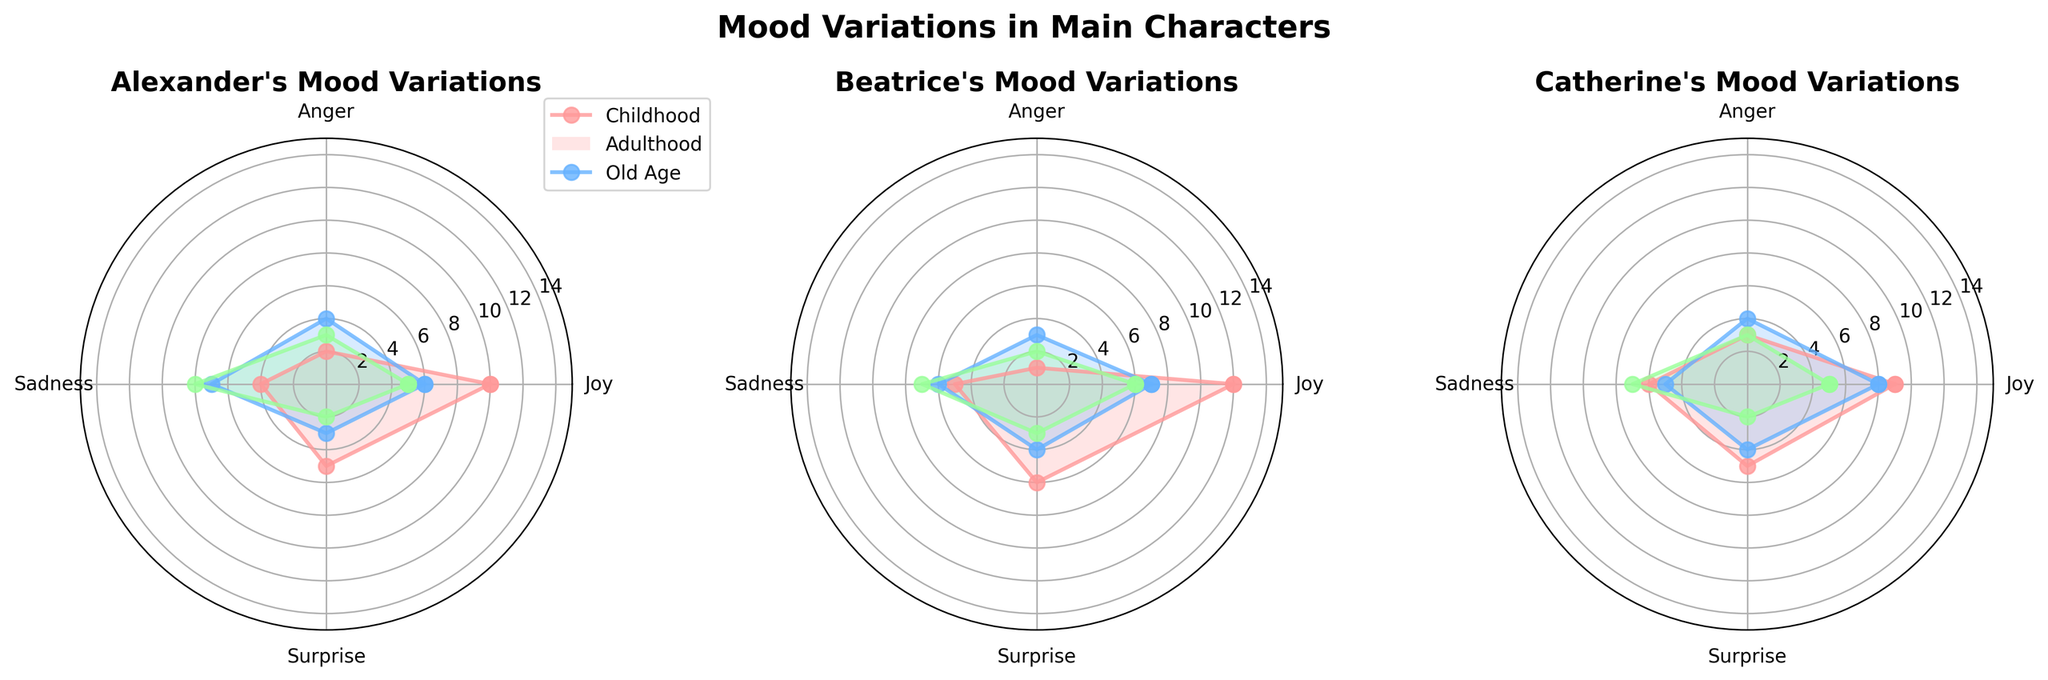What is the title of the plot? The title is indicated at the top center of the plot and reads "Mood Variations in Main Characters."
Answer: Mood Variations in Main Characters How many characters' mood variations are represented in the plot? There are three characters represented: Alexander, Beatrice, and Catherine. The plot has three sections, one for each character.
Answer: 3 Which character shows the highest Joy during Childhood? In the section for each character, the Joy value for Childhood can be compared. Beatrice shows the highest Joy with a value of 12.
Answer: Beatrice What is the difference in Sadness between Alexander's Adulthood and Old Age? Alexander's Sadness is 7 during Adulthood and 8 during Old Age. The difference is 8 - 7 = 1.
Answer: 1 Which stage shows the least Anger for Catherine? In Catherine's section, the plot for Anger values shows 1 for Childhood, 4 for Adulthood, and 3 for Old Age. Therefore, the least Anger is in Childhood with a value of 1.
Answer: Childhood What color represents Beatrice's Adulthood mood variations? The plot legend indicates the colors used for each stage. Beatrice's Adulthood is represented by the second color in the legend, which is a shade of blue.
Answer: Blue How does Surprise in Childhood compare between Alexander and Beatrice? For Childhood, compare the values of Surprise in each section. Alexander has a value of 5, and Beatrice has a value of 6. So, Beatrice has a higher Surprise in Childhood.
Answer: Beatrice has higher Surprise in Childhood What is the average Joy value for Catherine across all stages? Catherine's Joy values are 9 (Childhood), 8 (Adulthood), and 5 (Old Age). Sum them up: 9 + 8 + 5 = 22. The average is 22 / 3 = 7.33.
Answer: 7.33 Which character has the most consistent level of Joy across all stages? Consistency can be seen by the smallest variation in Joy values. Beatrice's Joy values are 12, 7, and 6 (variation: 6), whereas Alexander and Catherine have variations of 5 and 4, respectively.
Answer: Catherine has the smallest variation 